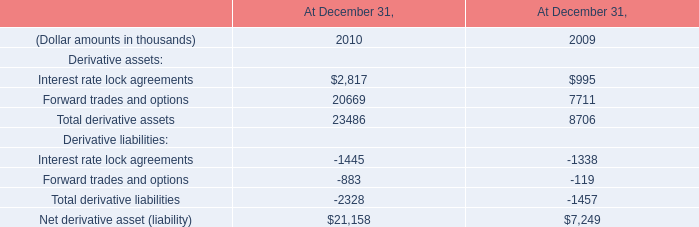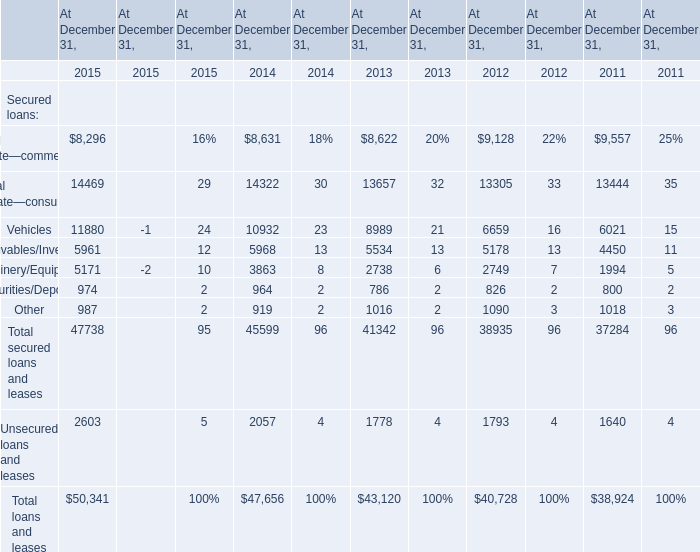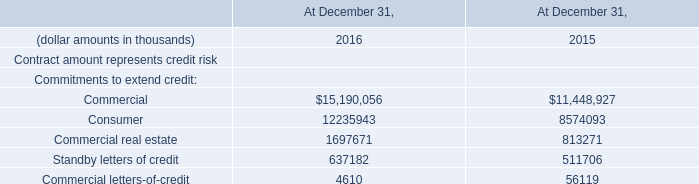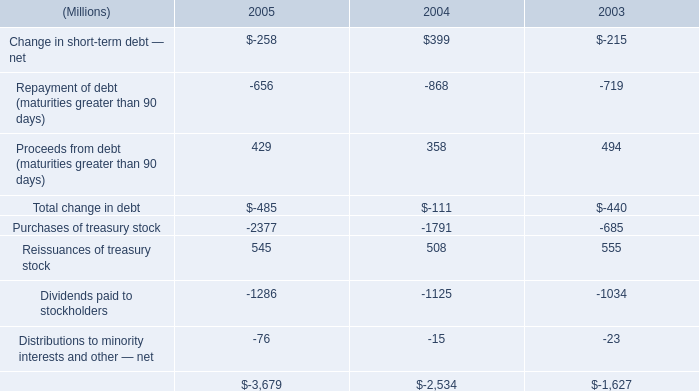What was the total amount of the Receivables/Inventory in the years where Vehicles greater than 10000? 
Computations: (5961 + 5968)
Answer: 11929.0. 